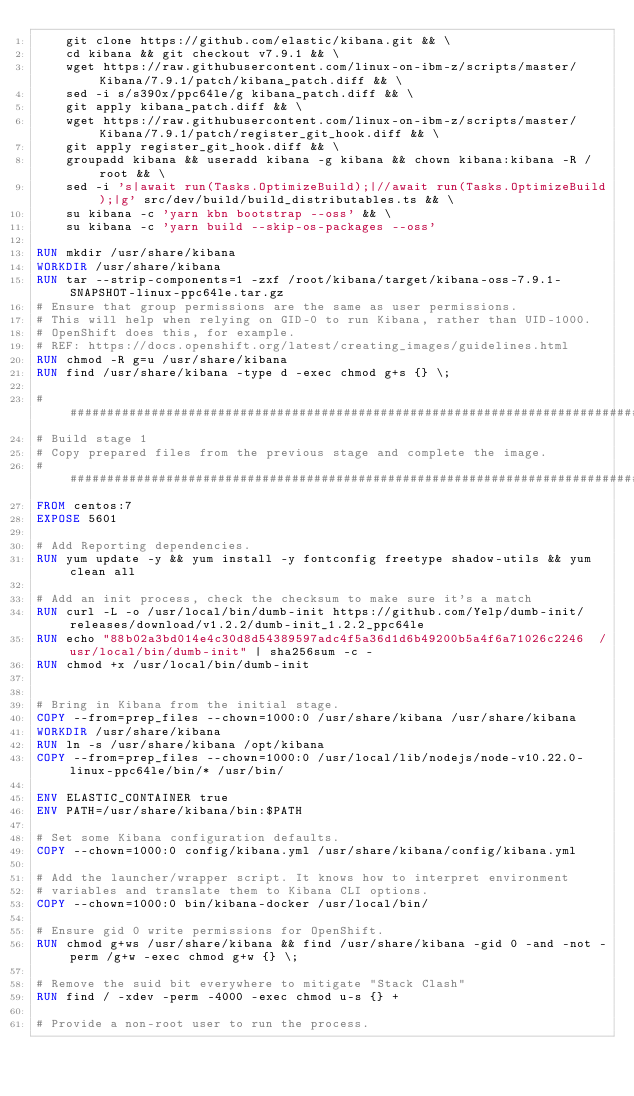<code> <loc_0><loc_0><loc_500><loc_500><_Dockerfile_>    git clone https://github.com/elastic/kibana.git && \
    cd kibana && git checkout v7.9.1 && \
    wget https://raw.githubusercontent.com/linux-on-ibm-z/scripts/master/Kibana/7.9.1/patch/kibana_patch.diff && \
    sed -i s/s390x/ppc64le/g kibana_patch.diff && \
    git apply kibana_patch.diff && \
    wget https://raw.githubusercontent.com/linux-on-ibm-z/scripts/master/Kibana/7.9.1/patch/register_git_hook.diff && \
    git apply register_git_hook.diff && \
    groupadd kibana && useradd kibana -g kibana && chown kibana:kibana -R /root && \
    sed -i 's|await run(Tasks.OptimizeBuild);|//await run(Tasks.OptimizeBuild);|g' src/dev/build/build_distributables.ts && \
    su kibana -c 'yarn kbn bootstrap --oss' && \
    su kibana -c 'yarn build --skip-os-packages --oss'

RUN mkdir /usr/share/kibana
WORKDIR /usr/share/kibana
RUN tar --strip-components=1 -zxf /root/kibana/target/kibana-oss-7.9.1-SNAPSHOT-linux-ppc64le.tar.gz
# Ensure that group permissions are the same as user permissions.
# This will help when relying on GID-0 to run Kibana, rather than UID-1000.
# OpenShift does this, for example.
# REF: https://docs.openshift.org/latest/creating_images/guidelines.html
RUN chmod -R g=u /usr/share/kibana
RUN find /usr/share/kibana -type d -exec chmod g+s {} \;

################################################################################
# Build stage 1
# Copy prepared files from the previous stage and complete the image.
################################################################################
FROM centos:7
EXPOSE 5601

# Add Reporting dependencies.
RUN yum update -y && yum install -y fontconfig freetype shadow-utils && yum clean all

# Add an init process, check the checksum to make sure it's a match
RUN curl -L -o /usr/local/bin/dumb-init https://github.com/Yelp/dumb-init/releases/download/v1.2.2/dumb-init_1.2.2_ppc64le
RUN echo "88b02a3bd014e4c30d8d54389597adc4f5a36d1d6b49200b5a4f6a71026c2246  /usr/local/bin/dumb-init" | sha256sum -c -
RUN chmod +x /usr/local/bin/dumb-init


# Bring in Kibana from the initial stage.
COPY --from=prep_files --chown=1000:0 /usr/share/kibana /usr/share/kibana
WORKDIR /usr/share/kibana
RUN ln -s /usr/share/kibana /opt/kibana
COPY --from=prep_files --chown=1000:0 /usr/local/lib/nodejs/node-v10.22.0-linux-ppc64le/bin/* /usr/bin/

ENV ELASTIC_CONTAINER true
ENV PATH=/usr/share/kibana/bin:$PATH

# Set some Kibana configuration defaults.
COPY --chown=1000:0 config/kibana.yml /usr/share/kibana/config/kibana.yml

# Add the launcher/wrapper script. It knows how to interpret environment
# variables and translate them to Kibana CLI options.
COPY --chown=1000:0 bin/kibana-docker /usr/local/bin/

# Ensure gid 0 write permissions for OpenShift.
RUN chmod g+ws /usr/share/kibana && find /usr/share/kibana -gid 0 -and -not -perm /g+w -exec chmod g+w {} \;

# Remove the suid bit everywhere to mitigate "Stack Clash"
RUN find / -xdev -perm -4000 -exec chmod u-s {} +

# Provide a non-root user to run the process.</code> 